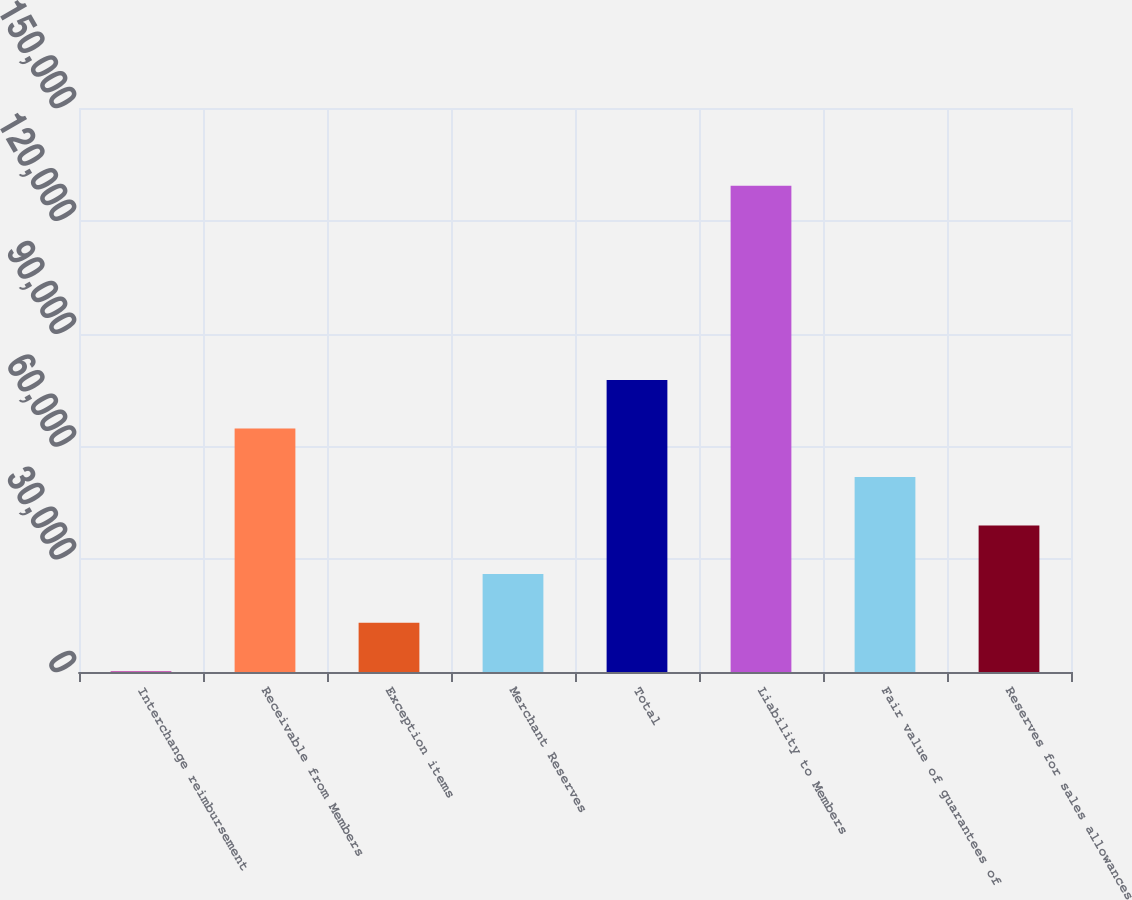Convert chart to OTSL. <chart><loc_0><loc_0><loc_500><loc_500><bar_chart><fcel>Interchange reimbursement<fcel>Receivable from Members<fcel>Exception items<fcel>Merchant Reserves<fcel>Total<fcel>Liability to Members<fcel>Fair value of guarantees of<fcel>Reserves for sales allowances<nl><fcel>222<fcel>64758.5<fcel>13129.3<fcel>26036.6<fcel>77665.8<fcel>129295<fcel>51851.2<fcel>38943.9<nl></chart> 